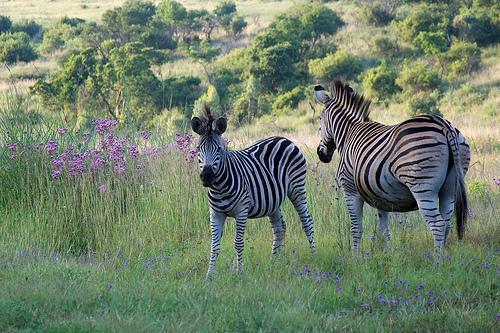How many of the zebras faces are visible?
Give a very brief answer. 1. 